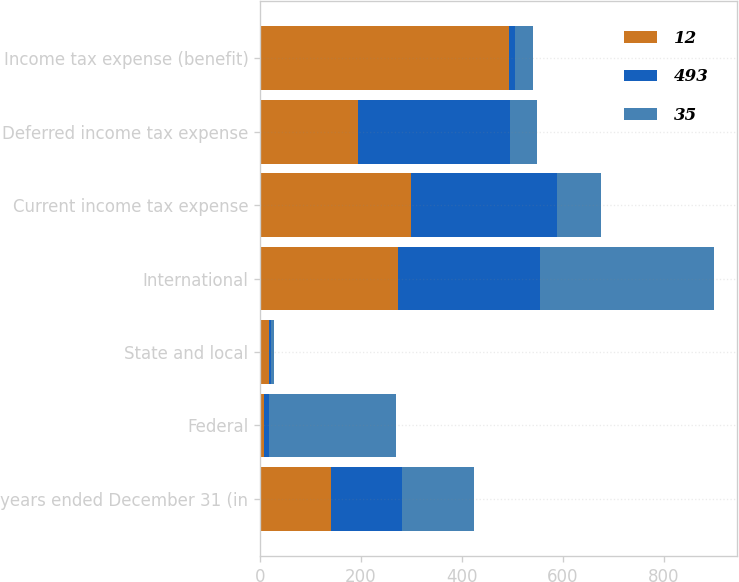Convert chart. <chart><loc_0><loc_0><loc_500><loc_500><stacked_bar_chart><ecel><fcel>years ended December 31 (in<fcel>Federal<fcel>State and local<fcel>International<fcel>Current income tax expense<fcel>Deferred income tax expense<fcel>Income tax expense (benefit)<nl><fcel>12<fcel>141<fcel>8<fcel>18<fcel>273<fcel>299<fcel>194<fcel>493<nl><fcel>493<fcel>141<fcel>10<fcel>3<fcel>282<fcel>289<fcel>301<fcel>12<nl><fcel>35<fcel>141<fcel>251<fcel>6<fcel>345<fcel>88<fcel>53<fcel>35<nl></chart> 